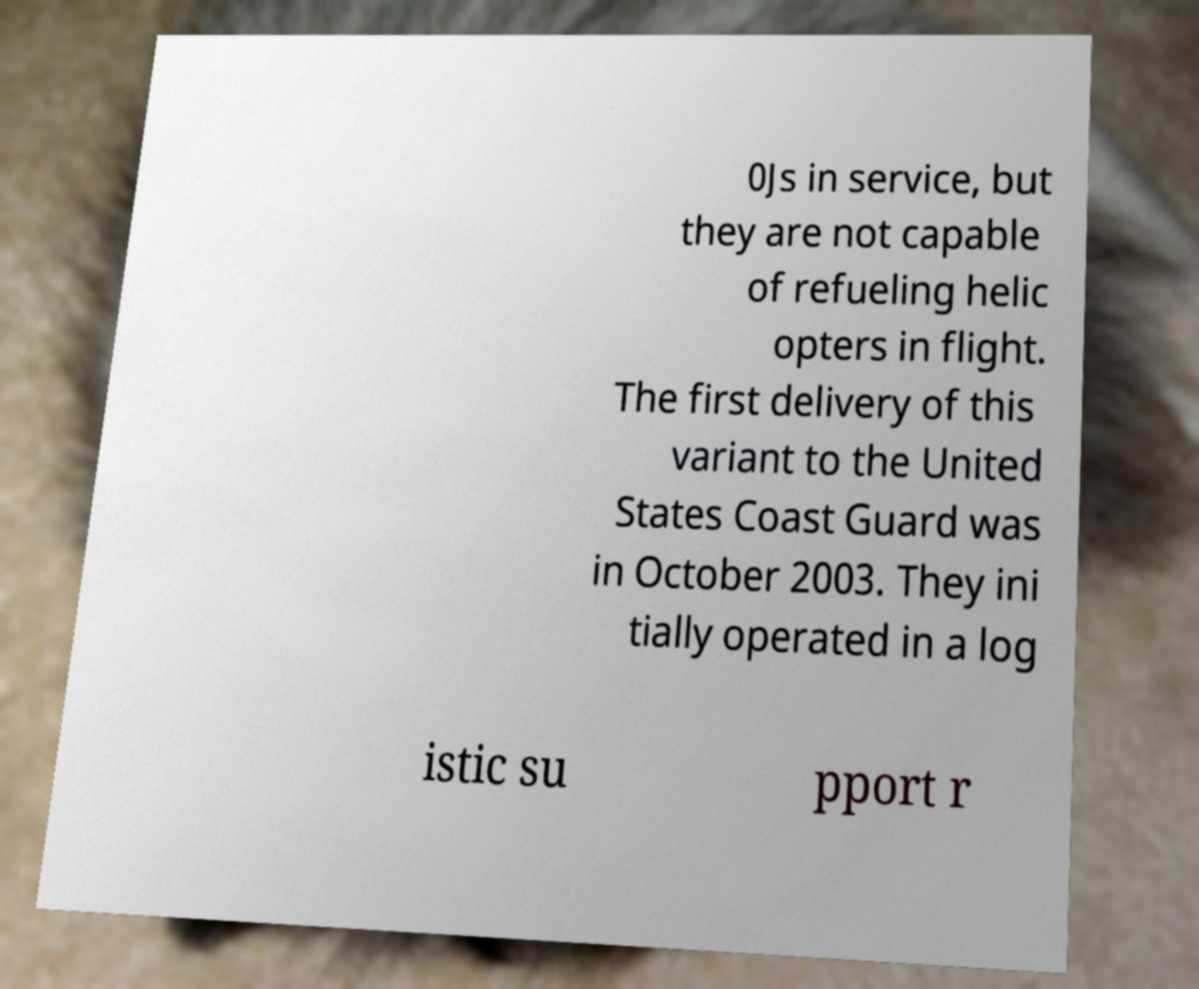Can you read and provide the text displayed in the image?This photo seems to have some interesting text. Can you extract and type it out for me? 0Js in service, but they are not capable of refueling helic opters in flight. The first delivery of this variant to the United States Coast Guard was in October 2003. They ini tially operated in a log istic su pport r 